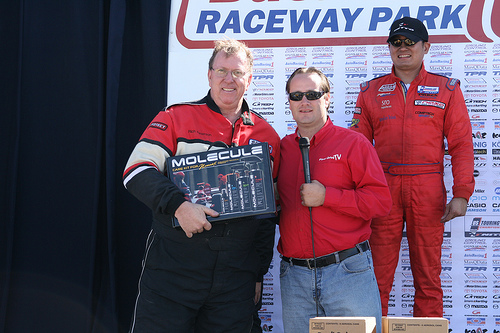<image>
Can you confirm if the big man is to the right of the small man? Yes. From this viewpoint, the big man is positioned to the right side relative to the small man. 